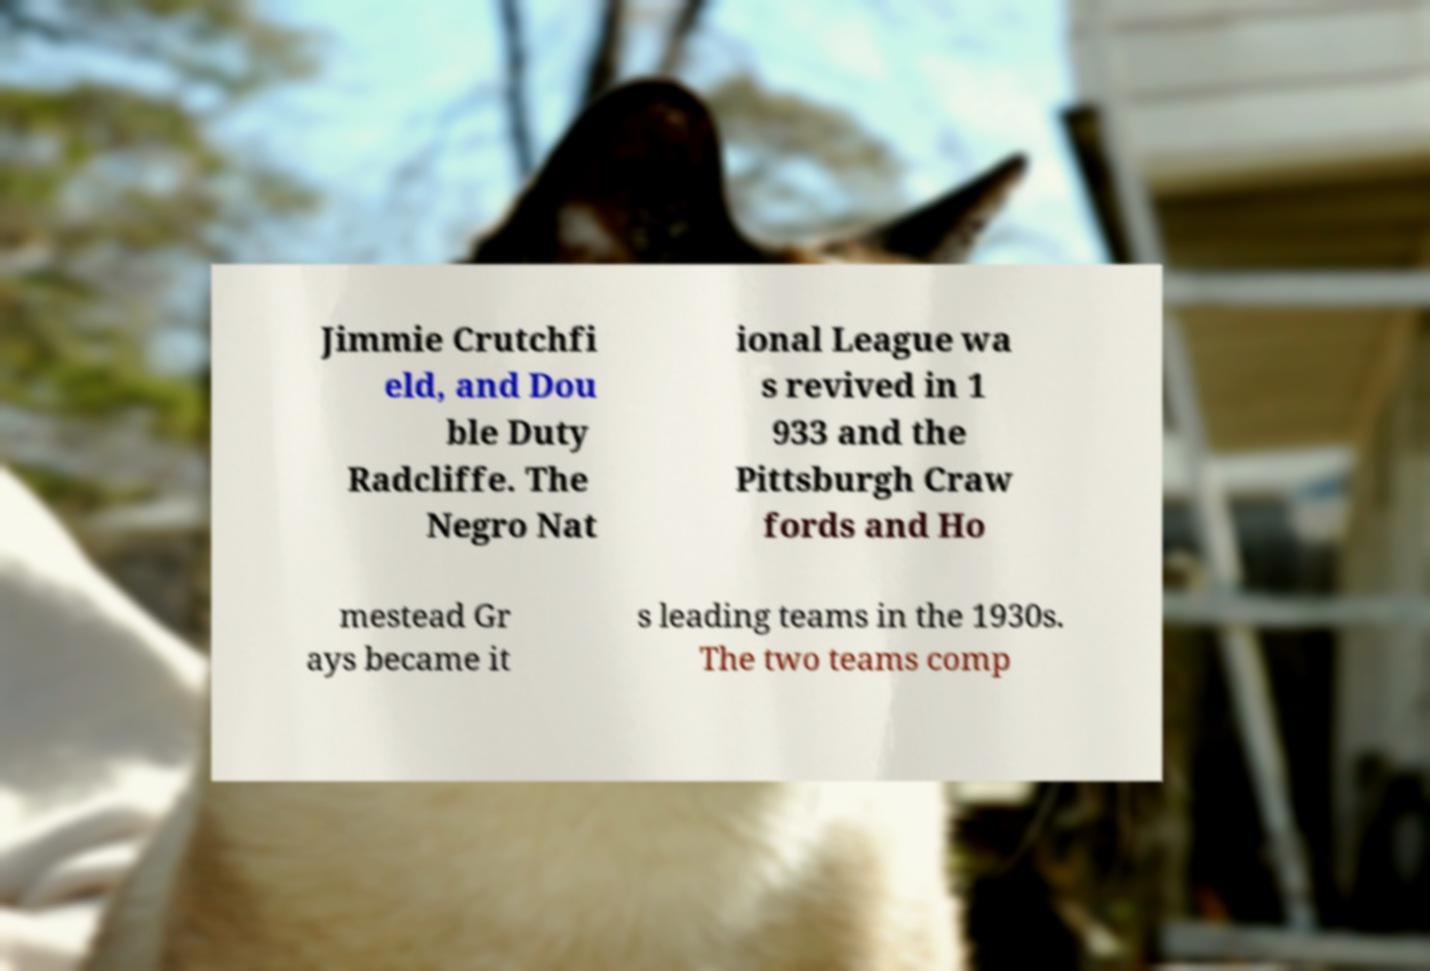Could you assist in decoding the text presented in this image and type it out clearly? Jimmie Crutchfi eld, and Dou ble Duty Radcliffe. The Negro Nat ional League wa s revived in 1 933 and the Pittsburgh Craw fords and Ho mestead Gr ays became it s leading teams in the 1930s. The two teams comp 